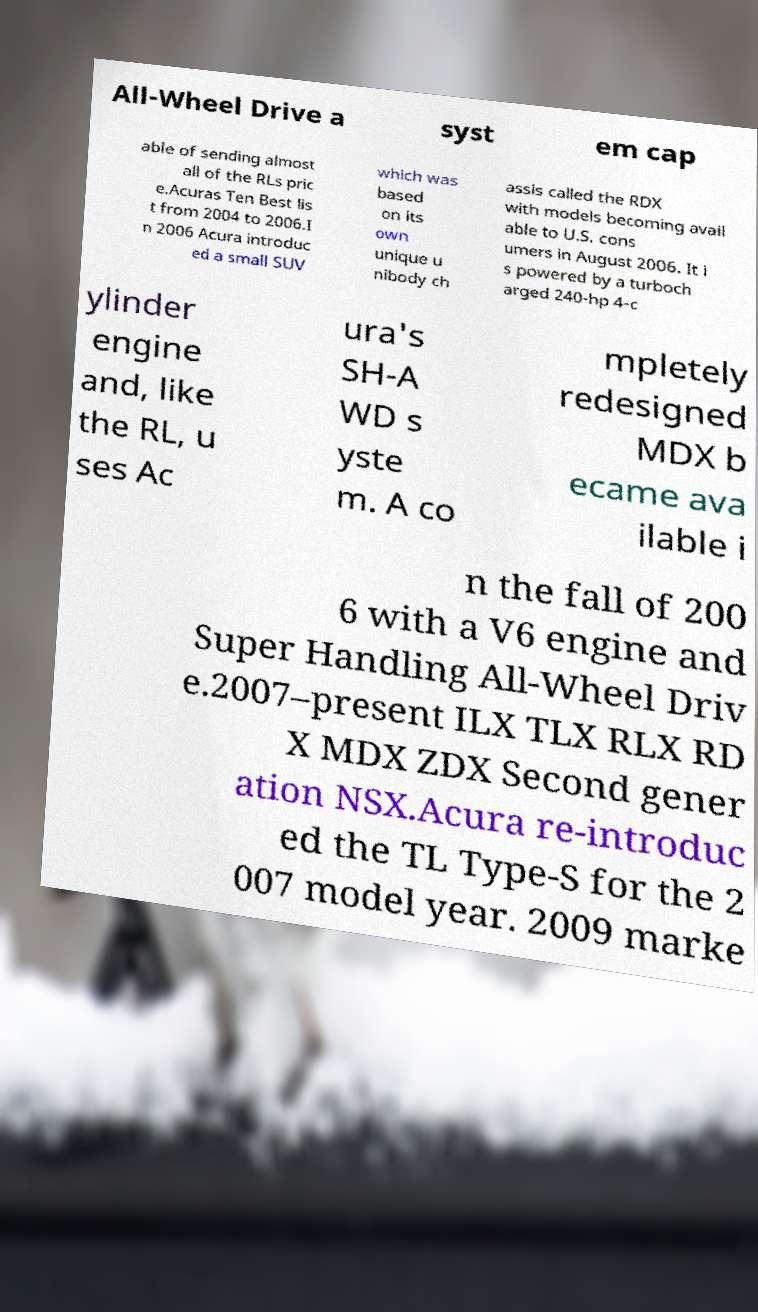Please read and relay the text visible in this image. What does it say? All-Wheel Drive a syst em cap able of sending almost all of the RLs pric e.Acuras Ten Best lis t from 2004 to 2006.I n 2006 Acura introduc ed a small SUV which was based on its own unique u nibody ch assis called the RDX with models becoming avail able to U.S. cons umers in August 2006. It i s powered by a turboch arged 240-hp 4-c ylinder engine and, like the RL, u ses Ac ura's SH-A WD s yste m. A co mpletely redesigned MDX b ecame ava ilable i n the fall of 200 6 with a V6 engine and Super Handling All-Wheel Driv e.2007–present ILX TLX RLX RD X MDX ZDX Second gener ation NSX.Acura re-introduc ed the TL Type-S for the 2 007 model year. 2009 marke 